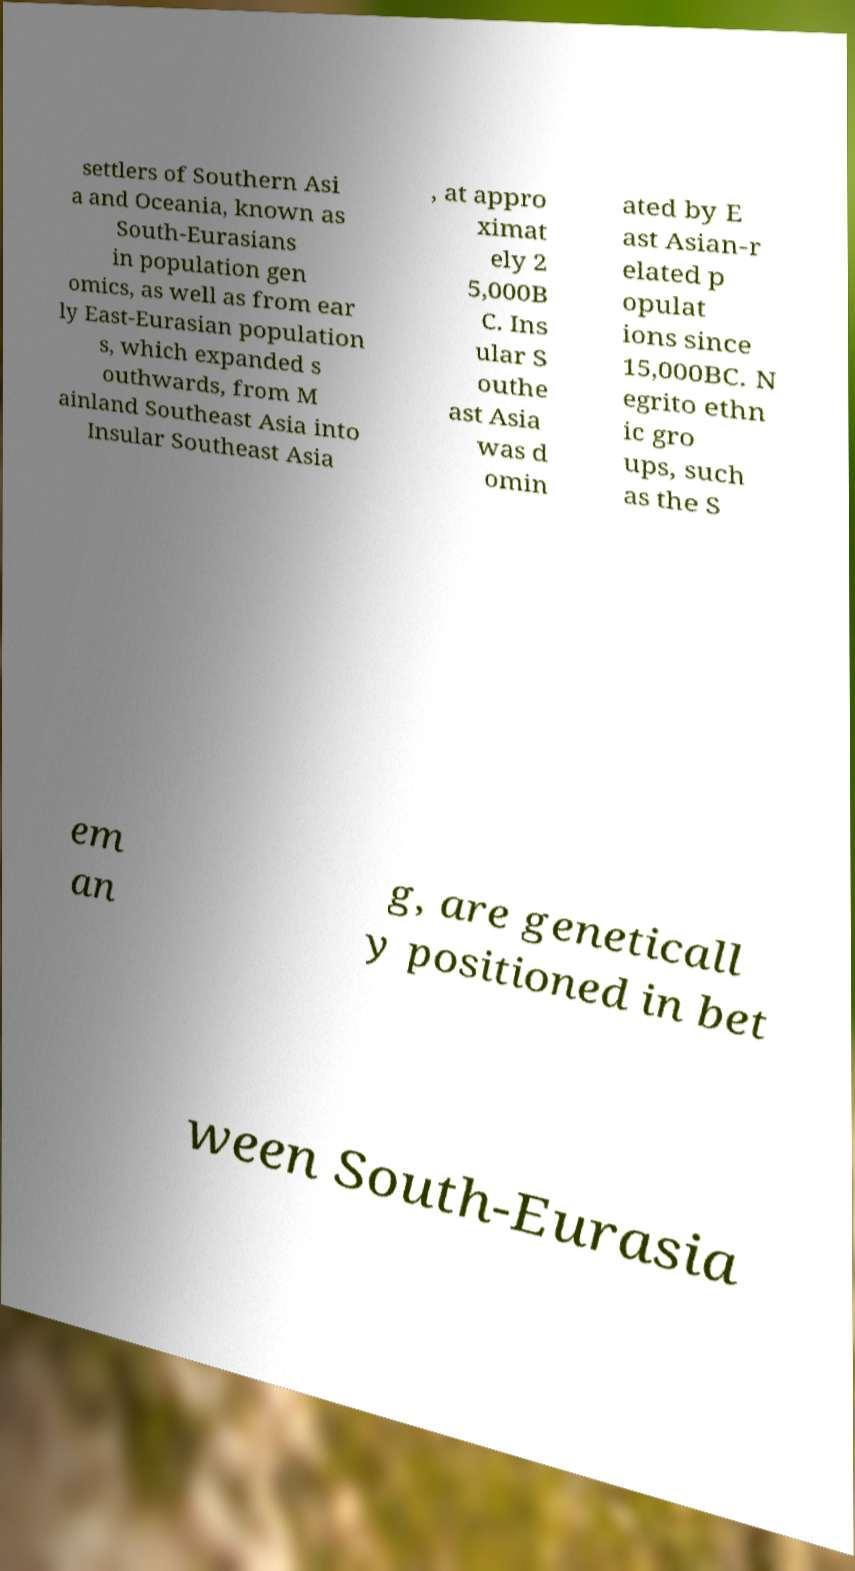Could you assist in decoding the text presented in this image and type it out clearly? settlers of Southern Asi a and Oceania, known as South-Eurasians in population gen omics, as well as from ear ly East-Eurasian population s, which expanded s outhwards, from M ainland Southeast Asia into Insular Southeast Asia , at appro ximat ely 2 5,000B C. Ins ular S outhe ast Asia was d omin ated by E ast Asian-r elated p opulat ions since 15,000BC. N egrito ethn ic gro ups, such as the S em an g, are geneticall y positioned in bet ween South-Eurasia 